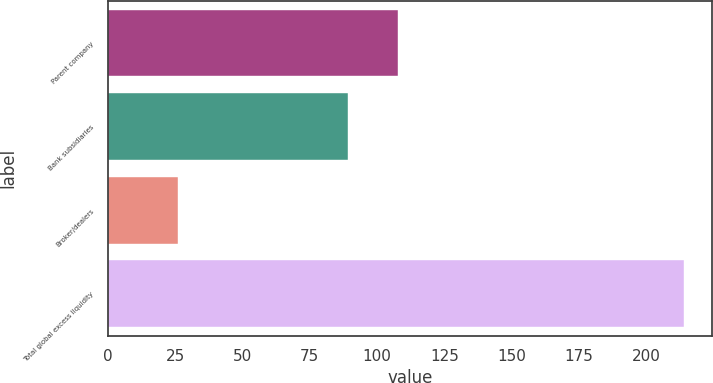<chart> <loc_0><loc_0><loc_500><loc_500><bar_chart><fcel>Parent company<fcel>Bank subsidiaries<fcel>Broker/dealers<fcel>Total global excess liquidity<nl><fcel>107.8<fcel>89<fcel>26<fcel>214<nl></chart> 